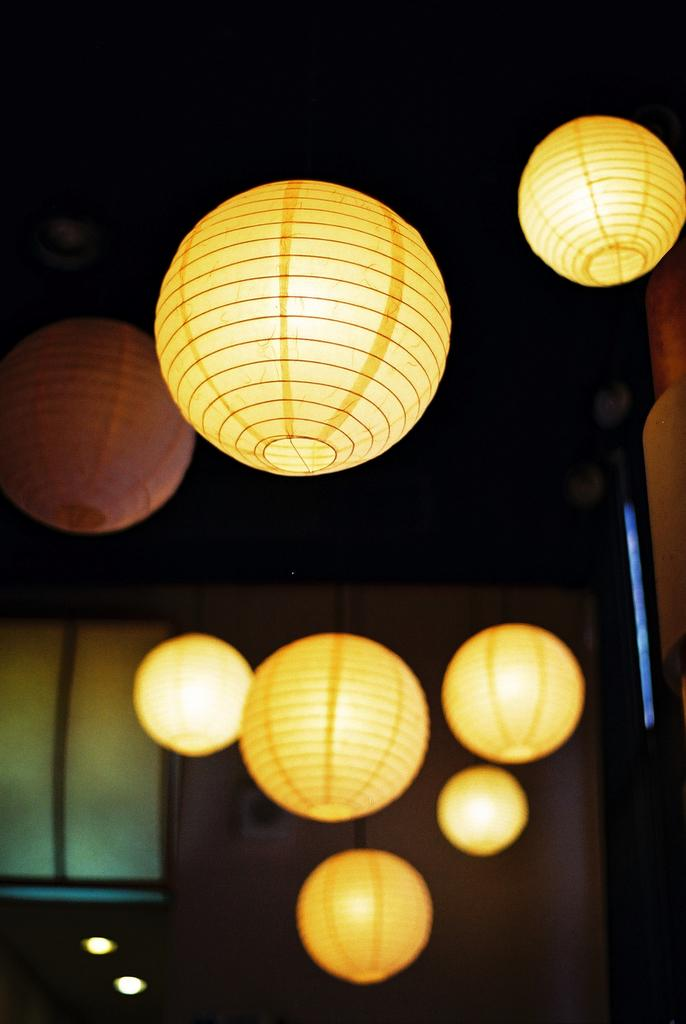What type of lighting is present on the roof in the image? There are lantern lamps with lights on the roof in the image. Where are the lantern lamps located? The lantern lamps are on a roof. What can be seen in the background of the image? There is a wall visible in the image. Is there any opening in the wall visible in the image? Yes, there is a window in the image. What type of mitten is being used to open the window in the image? There is no mitten present in the image, nor is anyone using a mitten to open the window. 